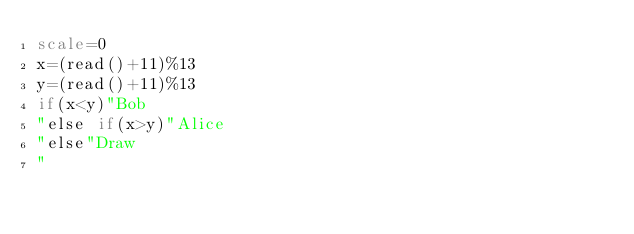<code> <loc_0><loc_0><loc_500><loc_500><_bc_>scale=0
x=(read()+11)%13
y=(read()+11)%13
if(x<y)"Bob
"else if(x>y)"Alice
"else"Draw
"
</code> 